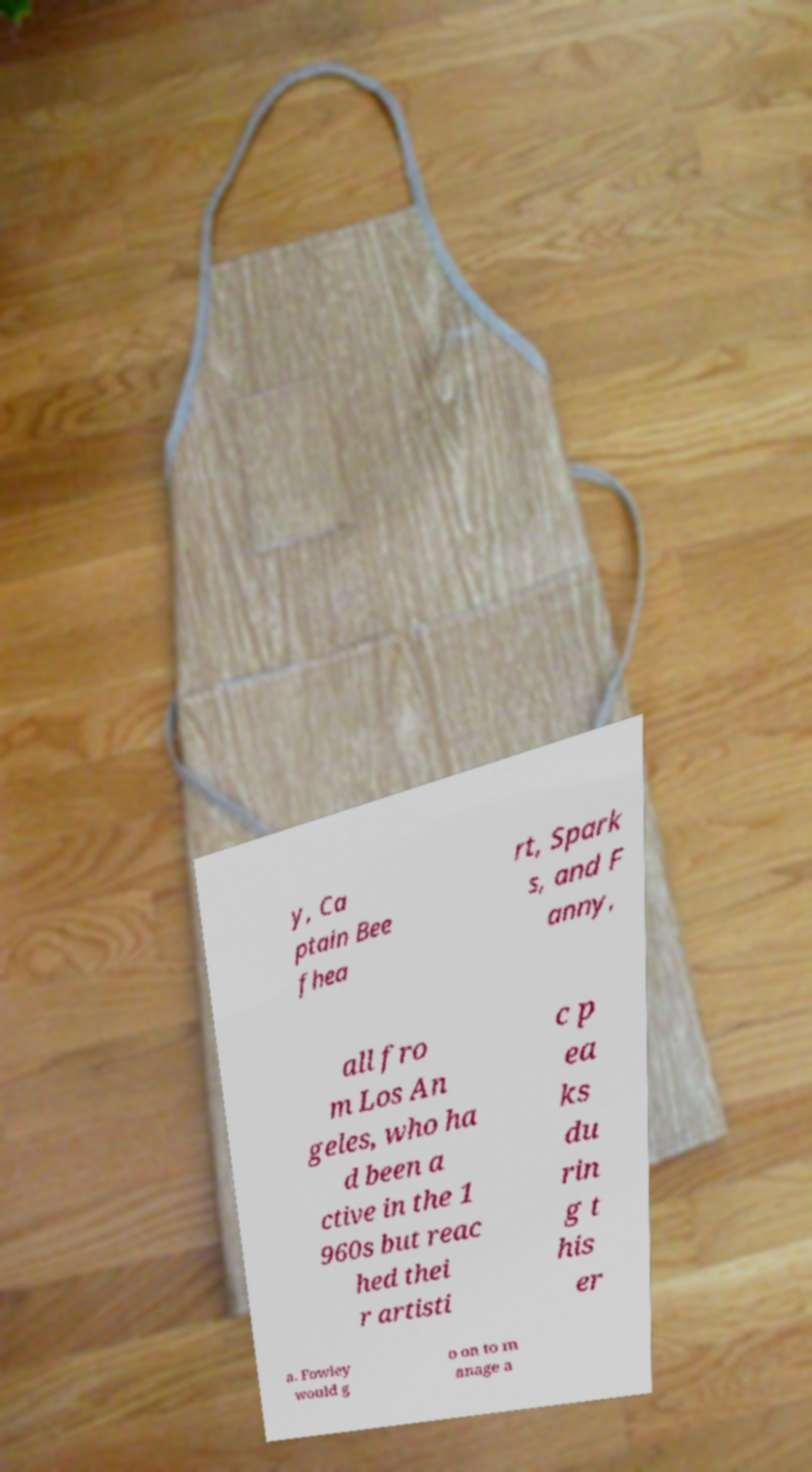Please identify and transcribe the text found in this image. y, Ca ptain Bee fhea rt, Spark s, and F anny, all fro m Los An geles, who ha d been a ctive in the 1 960s but reac hed thei r artisti c p ea ks du rin g t his er a. Fowley would g o on to m anage a 